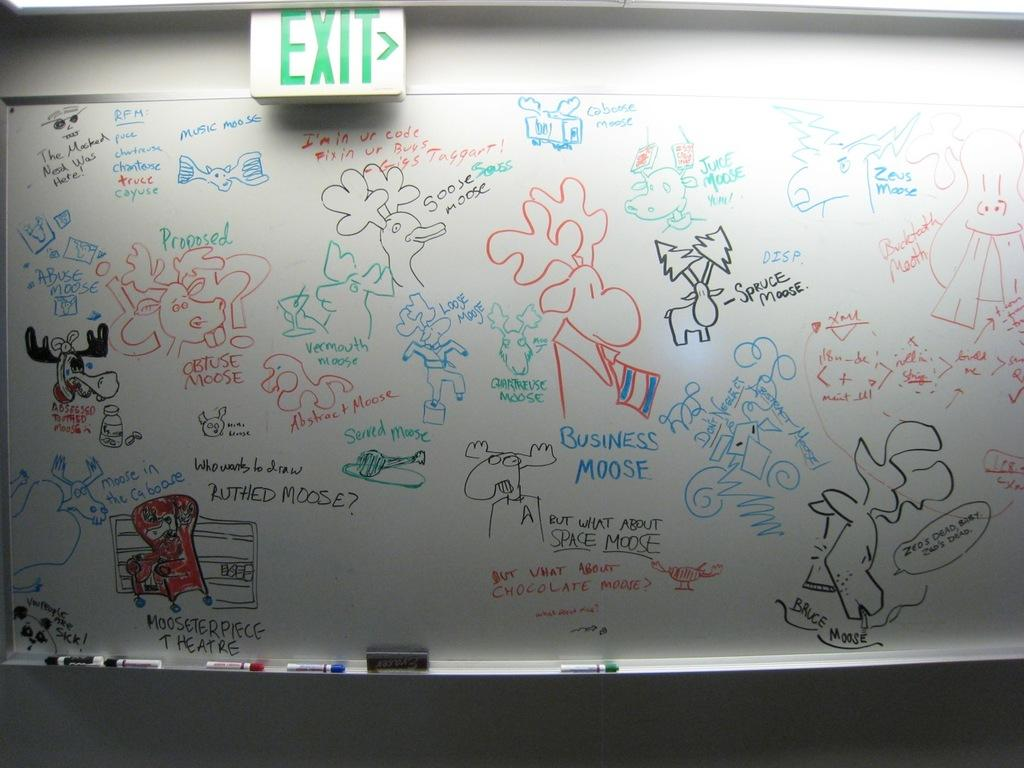Provide a one-sentence caption for the provided image. A whiteboard with several moose drawings under an EXIT sign. 